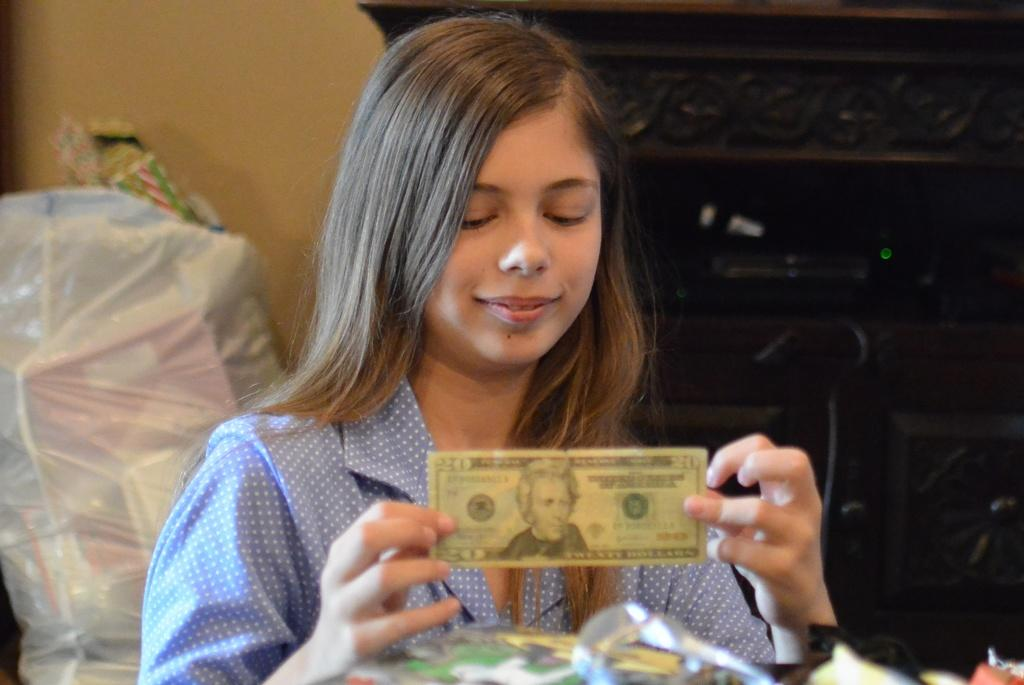Who is present in the image? There is a woman in the image. What is the woman holding in the image? The woman is holding money in the image. What is the woman wearing in the image? The woman is wearing a blue dress in the image. What can be seen in the white plastic cover? There are objects placed in a white color plastic cover in the image. What color is the wall in the image? The wall in the image is cream-colored. What type of trail can be seen in the image? There is no trail present in the image. What song is the woman singing in the image? There is no indication that the woman is singing in the image. 